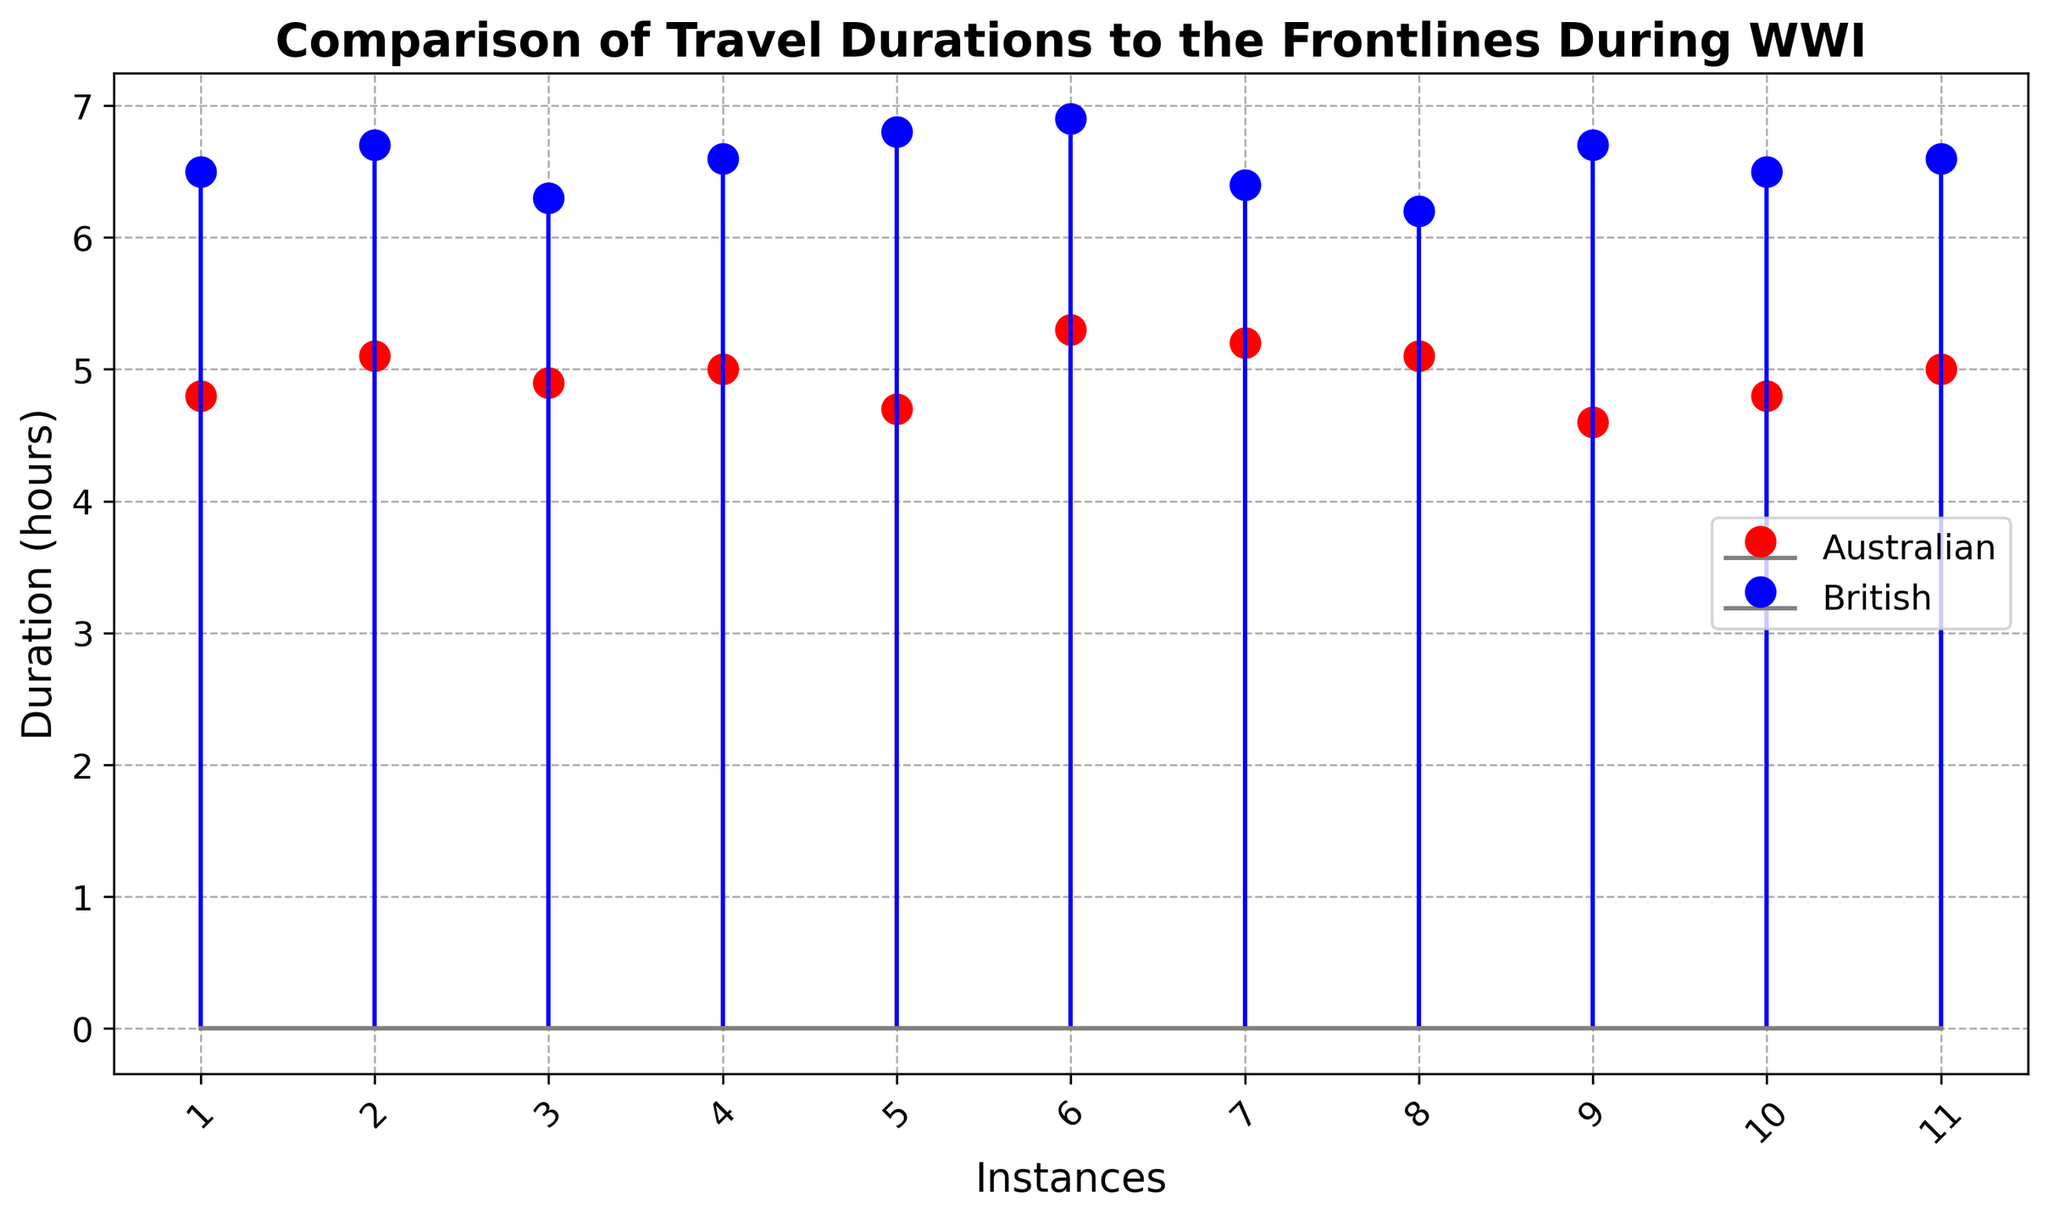What is the difference in travel duration between the first instance of Australian and British soldiers? The first instance for Australians is 4.8 hours and for the British is 6.5 hours. The difference between these values is 6.5 - 4.8 = 1.7 hours.
Answer: 1.7 hours Which nationality took the longest time to travel to the frontlines? The highest travel duration value among all instances is 6.9 hours, which is for the British soldiers.
Answer: British soldiers How many instances of travel durations are there for both nationalities? By counting the number of data points (markers) on the plot for each nationality, we can see that there are 11 instances for both Australian and British soldiers.
Answer: 11 instances each What is the average travel duration for Australian soldiers? Sum all the travel durations for the Australian soldiers and divide by the number of instances. (4.8 + 5.1 + 4.9 + 5.0 + 4.7 + 5.3 + 5.2 + 5.1 + 4.6 + 4.8 + 5.0) = 54.5 hours. Divide by 11: 54.5 / 11 = 4.95 hours.
Answer: 4.95 hours Is there any instance where the travel duration for Australian and British soldiers is the same? By examining the plot, we can confirm that in no instance do the orange and blue markers appear at the same height, indicating there is no same travel duration for both nationalities.
Answer: No On average, which nationality took longer to travel to the frontlines? Calculate the average travel duration for each nationality and compare them. The average for Australian soldiers is 4.95 hours and for British soldiers is 6.535 hours (sum all British durations: 6.5 + 6.7 + 6.3 + 6.6 + 6.8 + 6.9 + 6.4 + 6.2 + 6.7 + 6.5 + 6.6 = 71.9, then divide by 11: 71.9 / 11 = 6.535). Comparing 4.95 and 6.535, British soldiers took longer.
Answer: British soldiers What is the median travel duration for British soldiers? To find the median, arrange the British travel durations in ascending order and find the middle value. Ordered durations: 6.2, 6.3, 6.4, 6.5, 6.5, 6.6, 6.6, 6.7, 6.7, 6.8, 6.9. The middle value, or median, is 6.6 hours.
Answer: 6.6 hours How many times did the British travel duration exceed 6.5 hours? Count the blue markers that are above the 6.5 mark on the plot. There are 7 such instances: 6.7, 6.7, 6.6, 6.6, 6.8, 6.9, and 6.7, indicating the number of times is 7.
Answer: 7 times 